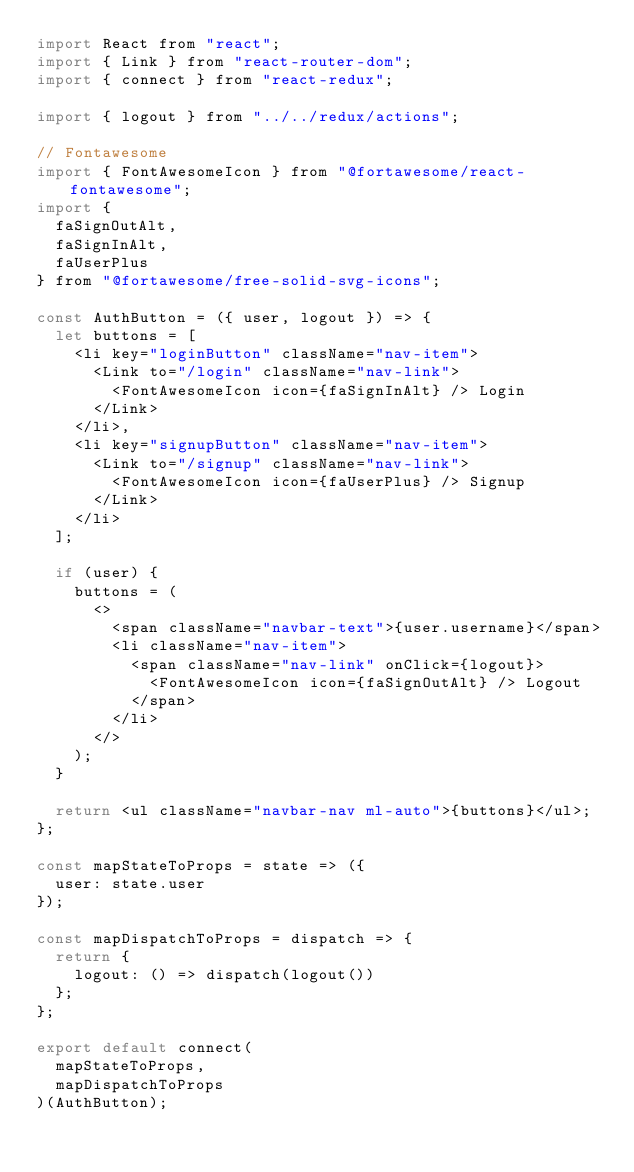<code> <loc_0><loc_0><loc_500><loc_500><_JavaScript_>import React from "react";
import { Link } from "react-router-dom";
import { connect } from "react-redux";

import { logout } from "../../redux/actions";

// Fontawesome
import { FontAwesomeIcon } from "@fortawesome/react-fontawesome";
import {
  faSignOutAlt,
  faSignInAlt,
  faUserPlus
} from "@fortawesome/free-solid-svg-icons";

const AuthButton = ({ user, logout }) => {
  let buttons = [
    <li key="loginButton" className="nav-item">
      <Link to="/login" className="nav-link">
        <FontAwesomeIcon icon={faSignInAlt} /> Login
      </Link>
    </li>,
    <li key="signupButton" className="nav-item">
      <Link to="/signup" className="nav-link">
        <FontAwesomeIcon icon={faUserPlus} /> Signup
      </Link>
    </li>
  ];

  if (user) {
    buttons = (
      <>
        <span className="navbar-text">{user.username}</span>
        <li className="nav-item">
          <span className="nav-link" onClick={logout}>
            <FontAwesomeIcon icon={faSignOutAlt} /> Logout
          </span>
        </li>
      </>
    );
  }

  return <ul className="navbar-nav ml-auto">{buttons}</ul>;
};

const mapStateToProps = state => ({
  user: state.user
});

const mapDispatchToProps = dispatch => {
  return {
    logout: () => dispatch(logout())
  };
};

export default connect(
  mapStateToProps,
  mapDispatchToProps
)(AuthButton);
</code> 